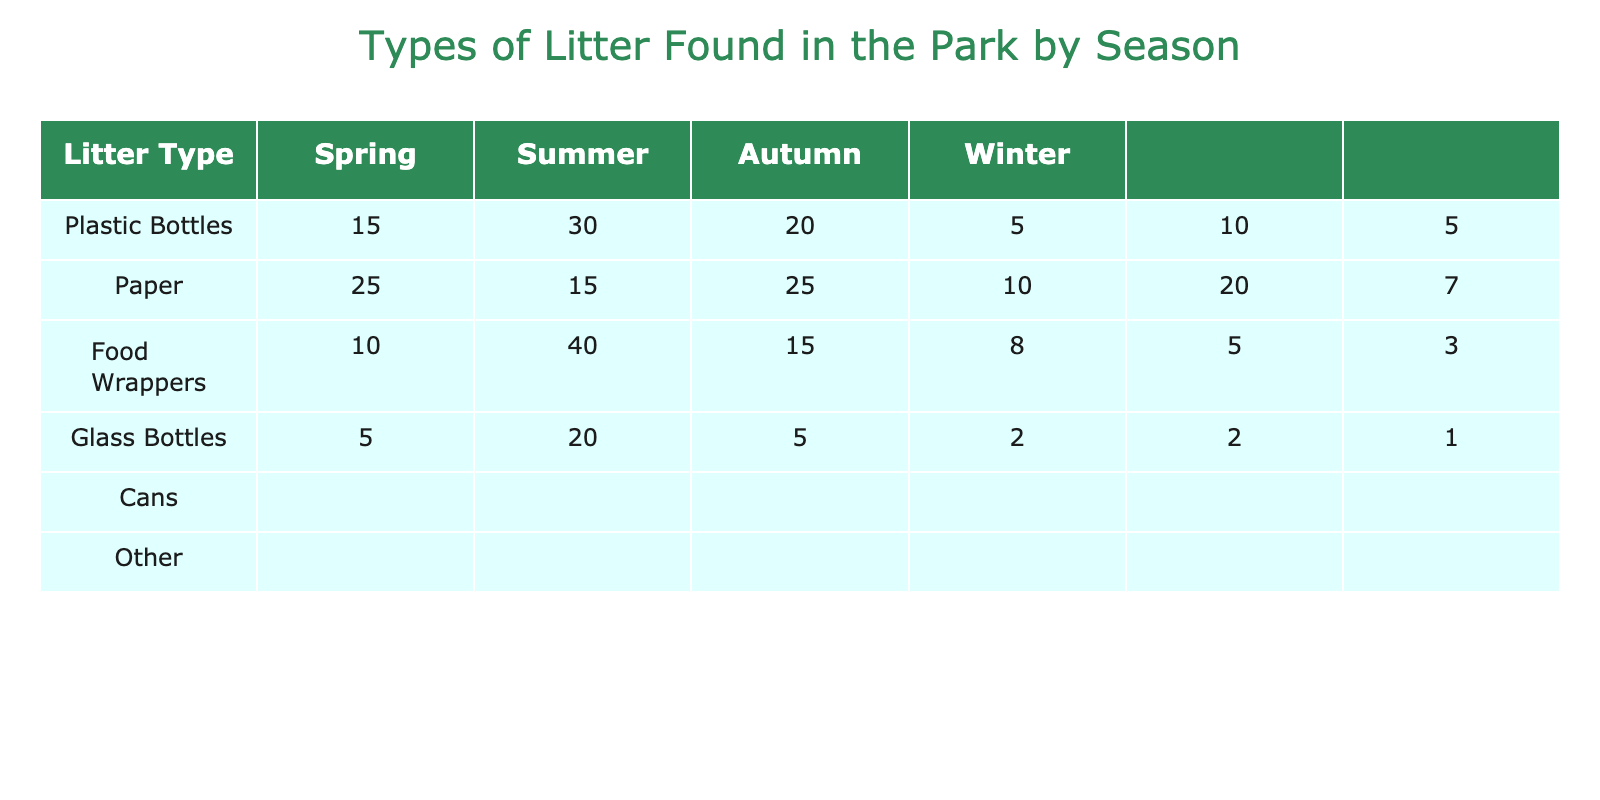What is the total number of Plastic Bottles found in Autumn? In the Autumn row of the table, we can see that the number of Plastic Bottles is listed as 10. Since we are only looking for the value in that specific cell, we can directly retrieve that number.
Answer: 10 Which season has the highest number of Food Wrappers? Looking at the Food Wrappers column, we see the following numbers: Spring has 20, Summer has 25, Autumn has 15, and Winter has 5. The highest number among these is in Summer with 25 Food Wrappers.
Answer: Summer Is there more paper litter found in Spring than in Winter? From the table, we see that there are 30 Paper items in Spring and 20 in Winter. Since 30 is greater than 20, the answer is yes, there is more paper litter in Spring.
Answer: Yes How many total cans are found across all seasons? To find the total number of cans, we need to sum the numbers in the Cans column: Spring has 10, Summer has 20, Autumn has 5, and Winter has 2. Adding these gives us: 10 + 20 + 5 + 2 = 37 cans total across all seasons.
Answer: 37 What is the average number of Glass Bottles found per season? We first look at the Glass Bottles column to find the numbers: Spring has 5, Summer has 10, Autumn has 8, and Winter has 2. To find the average, we first sum these values: 5 + 10 + 8 + 2 = 25. Since there are 4 seasons, we divide this sum by 4: 25/4 = 6.25. Therefore, the average number of Glass Bottles found per season is 6.25.
Answer: 6.25 Which type of litter is the least found in Winter? In the Winter row, we see the following counts: Plastic Bottles is 5, Paper is 20, Food Wrappers is 5, Glass Bottles is 2, Cans is 2, and Other is 1. The least count is 1 for "Other."
Answer: Other Is there more total litter in Spring or Summer? To find the total number of litter in each season, we sum the counts for Spring: 15 (Plastic) + 30 (Paper) + 20 (Food Wrappers) + 5 (Glass) + 10 (Cans) + 5 (Other) = 85. For Summer, we do the same: 25 (Plastic) + 15 (Paper) + 25 (Food Wrappers) + 10 (Glass) + 20 (Cans) + 7 (Other) = 102. Since 102 is greater than 85, there is more total litter in Summer.
Answer: Summer What is the difference in the number of Paper items found between Autumn and Winter? Looking at the Paper column, Autumn has 40 and Winter has 20. To find the difference, we subtract Winter's value from Autumn's: 40 - 20 = 20. Therefore, the difference in Paper items between Autumn and Winter is 20.
Answer: 20 